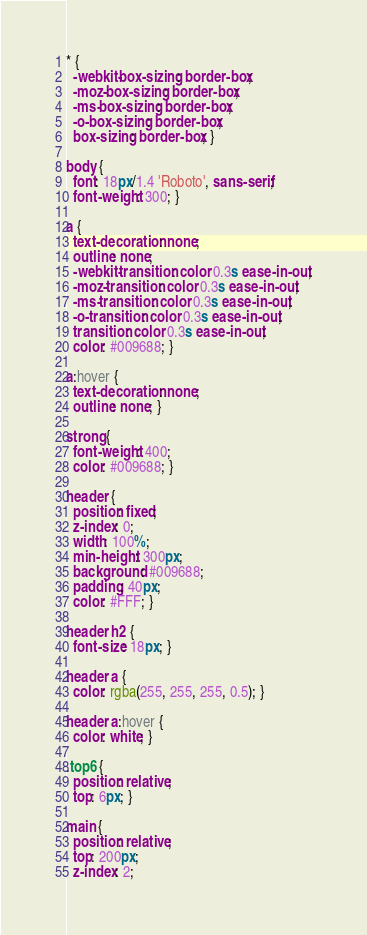<code> <loc_0><loc_0><loc_500><loc_500><_CSS_>* {
  -webkit-box-sizing: border-box;
  -moz-box-sizing: border-box;
  -ms-box-sizing: border-box;
  -o-box-sizing: border-box;
  box-sizing: border-box; }

body {
  font: 18px/1.4 'Roboto', sans-serif;
  font-weight: 300; }

a {
  text-decoration: none;
  outline: none;
  -webkit-transition: color 0.3s ease-in-out;
  -moz-transition: color 0.3s ease-in-out;
  -ms-transition: color 0.3s ease-in-out;
  -o-transition: color 0.3s ease-in-out;
  transition: color 0.3s ease-in-out;
  color: #009688; }

a:hover {
  text-decoration: none;
  outline: none; }

strong {
  font-weight: 400;
  color: #009688; }

header {
  position: fixed;
  z-index: 0;
  width: 100%;
  min-height: 300px;
  background: #009688;
  padding: 40px;
  color: #FFF; }

header h2 {
  font-size: 18px; }

header a {
  color: rgba(255, 255, 255, 0.5); }

header a:hover {
  color: white; }

.top6 {
  position: relative;
  top: 6px; }

main {
  position: relative;
  top: 200px;
  z-index: 2;</code> 